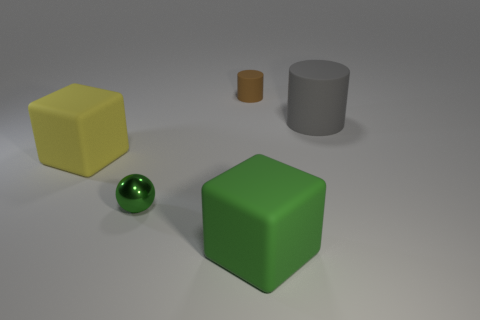Is the number of large matte cylinders that are right of the big gray matte thing less than the number of small red cylinders?
Provide a succinct answer. No. The matte thing that is to the right of the small metal sphere and to the left of the big green block has what shape?
Offer a very short reply. Cylinder. The tiny brown thing that is made of the same material as the yellow object is what shape?
Provide a short and direct response. Cylinder. What is the material of the green thing that is behind the green rubber cube?
Keep it short and to the point. Metal. Does the rubber cylinder right of the brown rubber thing have the same size as the cylinder that is to the left of the big gray matte thing?
Provide a succinct answer. No. What color is the tiny rubber thing?
Ensure brevity in your answer.  Brown. Is the shape of the large object left of the tiny brown thing the same as  the big green rubber object?
Offer a terse response. Yes. What is the sphere made of?
Give a very brief answer. Metal. There is another object that is the same size as the brown object; what shape is it?
Keep it short and to the point. Sphere. Are there any large rubber cylinders of the same color as the sphere?
Provide a succinct answer. No. 